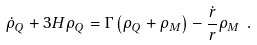<formula> <loc_0><loc_0><loc_500><loc_500>\dot { \rho } _ { Q } + 3 H \rho _ { Q } = \Gamma \left ( \rho _ { Q } + \rho _ { M } \right ) - \frac { \dot { r } } { r } \rho _ { M } \ .</formula> 